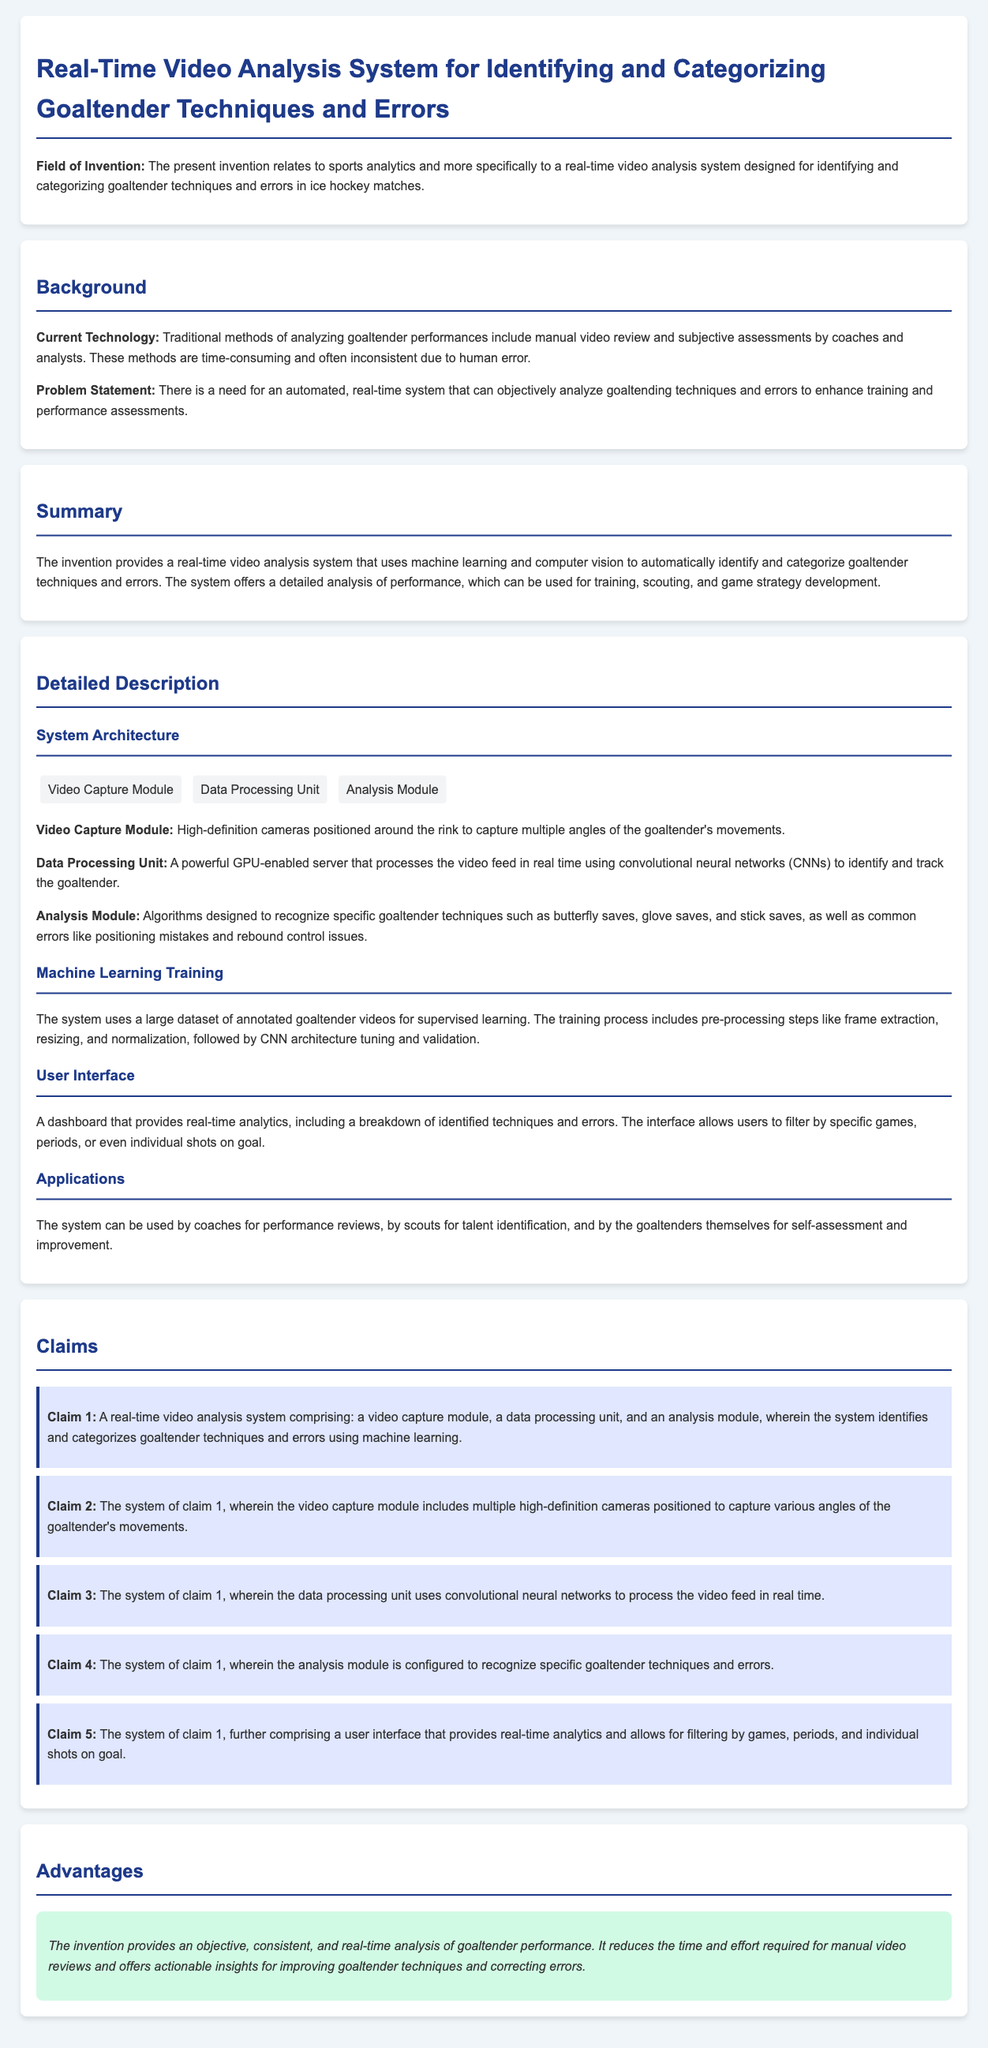What is the field of invention? The field of invention is stated in the document as relating to sports analytics, specifically for analyzing goaltender techniques and errors in ice hockey matches.
Answer: sports analytics What is the main problem addressed by the invention? The problem statement in the document highlights the need for an automated, real-time system to analyze goaltending techniques and errors, enhancing training and performance assessments.
Answer: need for an automated, real-time system How many claims are listed in the document? The number of claims can be counted in the "Claims" section, where five distinct claims are outlined.
Answer: five What module is responsible for capturing video in the system? The structure of the system is detailed, and it indicates that the "Video Capture Module" is responsible for capturing video.
Answer: Video Capture Module Which machine learning technique is employed in the data processing unit? The document specifies that the data processing unit uses "convolutional neural networks" to process video feeds in real time.
Answer: convolutional neural networks What are the two main applications of the system mentioned? The applications mentioned are for performance reviews by coaches and for talent identification by scouts, indicating its usefulness in both training and scouting.
Answer: performance reviews and talent identification What is one advantage of the invention? The advantages are highlighted in the "Advantages" section, claiming it offers an objective, consistent, and real-time analysis of goaltender performance.
Answer: objective, consistent, and real-time analysis What type of user interface is provided? The document states that there is a "dashboard" that provides real-time analytics, allowing for filtering of games, periods, and shots on goal.
Answer: dashboard What is the main purpose of the analysis module? The analysis module is described as being configured to recognize specific goaltender techniques and errors, indicating its role in performance evaluation.
Answer: to recognize specific goaltender techniques and errors 